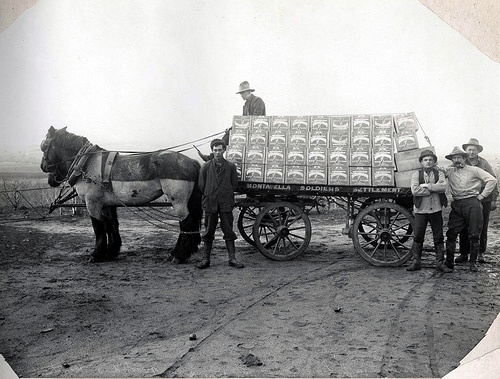Describe the objects in this image and their specific colors. I can see horse in darkgray, black, and gray tones, people in darkgray, black, and gray tones, people in darkgray, black, gray, and lightgray tones, people in darkgray, black, gray, and lightgray tones, and people in darkgray, black, gray, and lightgray tones in this image. 